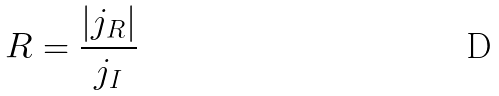Convert formula to latex. <formula><loc_0><loc_0><loc_500><loc_500>R = \frac { | j _ { R } | } { j _ { I } }</formula> 